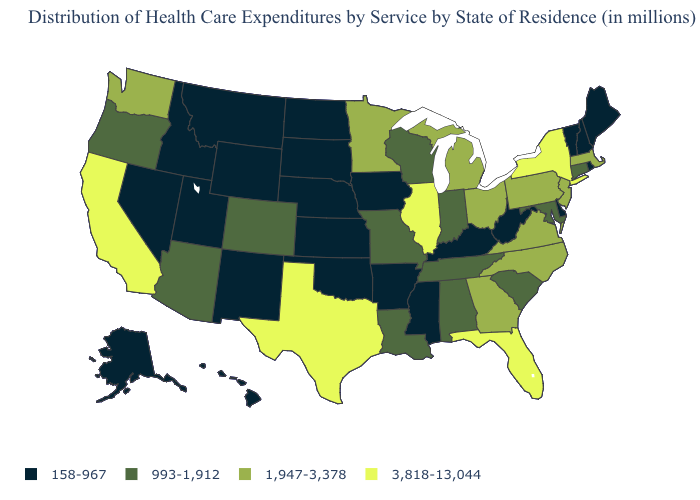Name the states that have a value in the range 3,818-13,044?
Short answer required. California, Florida, Illinois, New York, Texas. How many symbols are there in the legend?
Short answer required. 4. Which states hav the highest value in the MidWest?
Keep it brief. Illinois. What is the value of Alaska?
Write a very short answer. 158-967. Does the map have missing data?
Write a very short answer. No. Name the states that have a value in the range 1,947-3,378?
Write a very short answer. Georgia, Massachusetts, Michigan, Minnesota, New Jersey, North Carolina, Ohio, Pennsylvania, Virginia, Washington. What is the value of Maryland?
Be succinct. 993-1,912. Name the states that have a value in the range 993-1,912?
Be succinct. Alabama, Arizona, Colorado, Connecticut, Indiana, Louisiana, Maryland, Missouri, Oregon, South Carolina, Tennessee, Wisconsin. Which states have the highest value in the USA?
Give a very brief answer. California, Florida, Illinois, New York, Texas. What is the value of California?
Answer briefly. 3,818-13,044. What is the value of Utah?
Quick response, please. 158-967. Name the states that have a value in the range 3,818-13,044?
Write a very short answer. California, Florida, Illinois, New York, Texas. What is the lowest value in the USA?
Short answer required. 158-967. What is the lowest value in the South?
Concise answer only. 158-967. Does Florida have the lowest value in the USA?
Answer briefly. No. 